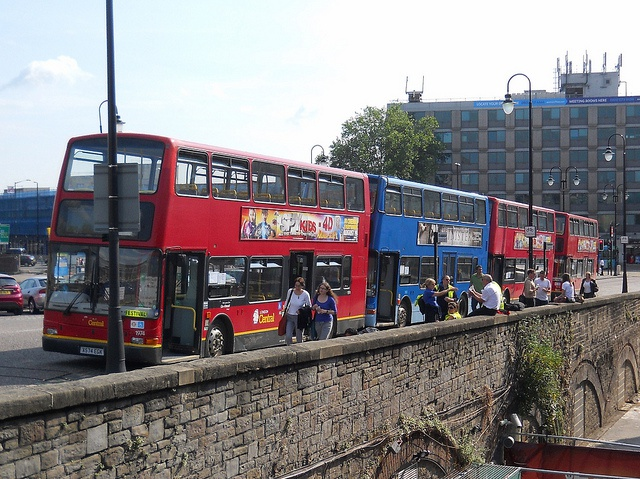Describe the objects in this image and their specific colors. I can see bus in lightblue, black, gray, brown, and maroon tones, bus in lightblue, black, gray, blue, and navy tones, bus in lightblue, gray, black, brown, and maroon tones, bus in lightblue, gray, black, and brown tones, and people in lightblue, black, gray, and darkgray tones in this image. 